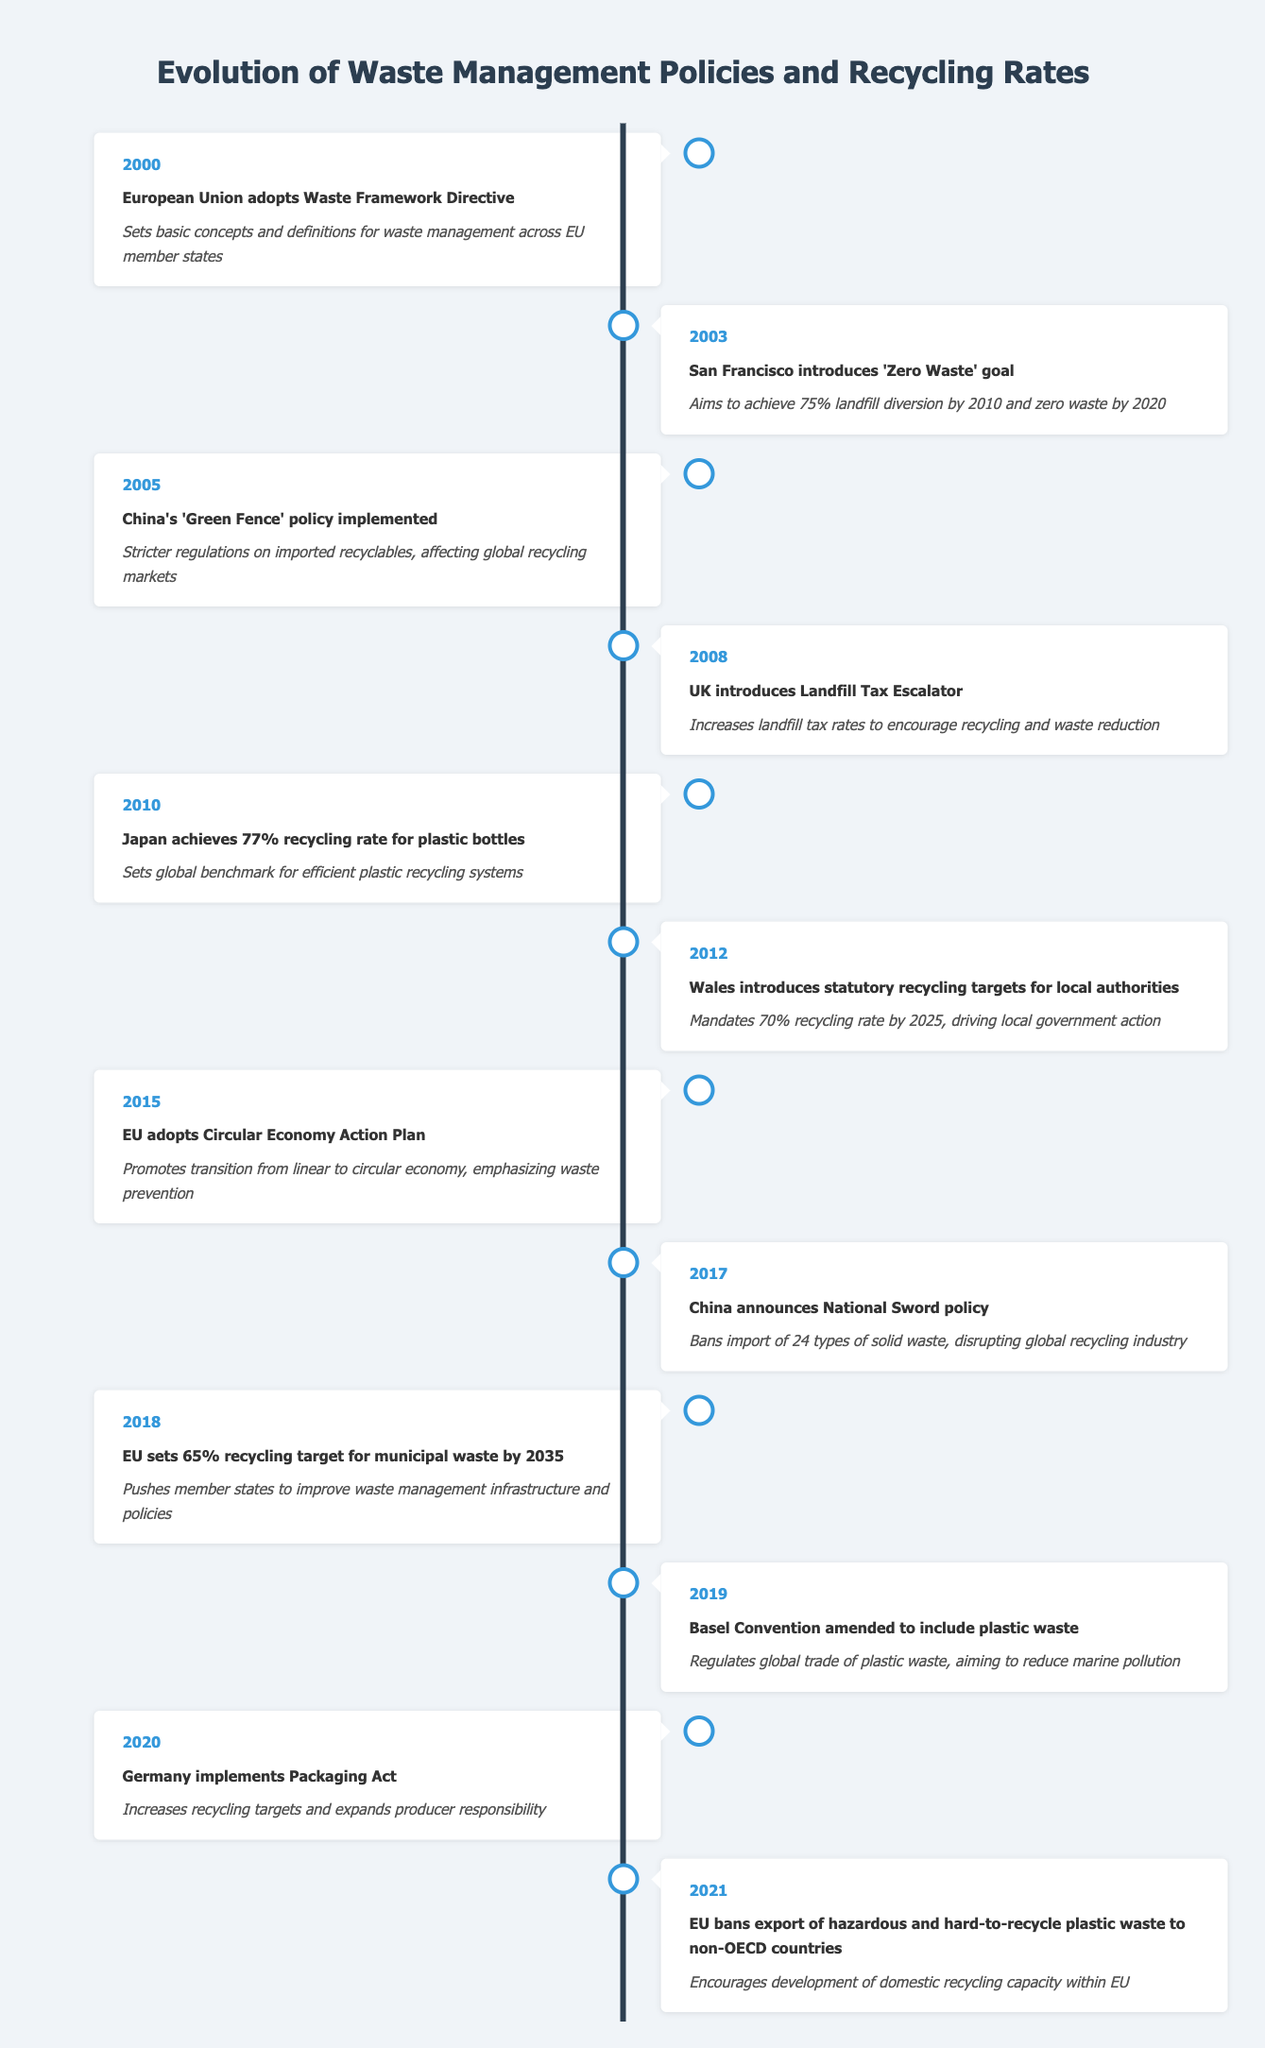What year did the European Union adopt the Waste Framework Directive? The table indicates that the event occurred in 2000.
Answer: 2000 What was the main goal of San Francisco's 'Zero Waste' initiative? According to the timeline, the goal was to achieve 75% landfill diversion by 2010 and zero waste by 2020.
Answer: Achieve 75% landfill diversion by 2010 and zero waste by 2020 Which country achieved a 77% recycling rate for plastic bottles in 2010? The timeline shows that Japan achieved this recycling rate in 2010.
Answer: Japan True or False: The EU adopted the Circular Economy Action Plan before China implemented its National Sword policy. The table indicates that the EU adopted the Circular Economy Action Plan in 2015 and China announced its National Sword policy in 2017, making the statement true.
Answer: True What impact did the UK's Landfill Tax Escalator have according to the table? The timeline states that it increased landfill tax rates to encourage recycling and waste reduction.
Answer: Increased landfill tax rates to encourage recycling and waste reduction What was the first event listed in the timeline, and what was its impact? The first event is the adoption of the Waste Framework Directive by the EU in 2000, which set basic concepts and definitions for waste management across EU member states.
Answer: European Union adopts Waste Framework Directive; Sets basic concepts and definitions for waste management across EU member states List the years in which significant recycling policies were implemented or amended between 2010 and 2021. By reviewing the timeline, significant recycling-related events occurred in 2010 (Japan), 2012 (Wales), 2020 (Germany), and 2021 (EU).
Answer: 2010, 2012, 2020, 2021 How many years were there between the adoption of the Waste Framework Directive and the implementation of China’s 'Green Fence' policy? The Waste Framework Directive was adopted in 2000 and the 'Green Fence' policy was implemented in 2005; therefore, the difference is 5 years.
Answer: 5 years Which region set a recycling target of 65% for municipal waste by 2035, and when was this enacted? The EU set this target in 2018.
Answer: EU, 2018 